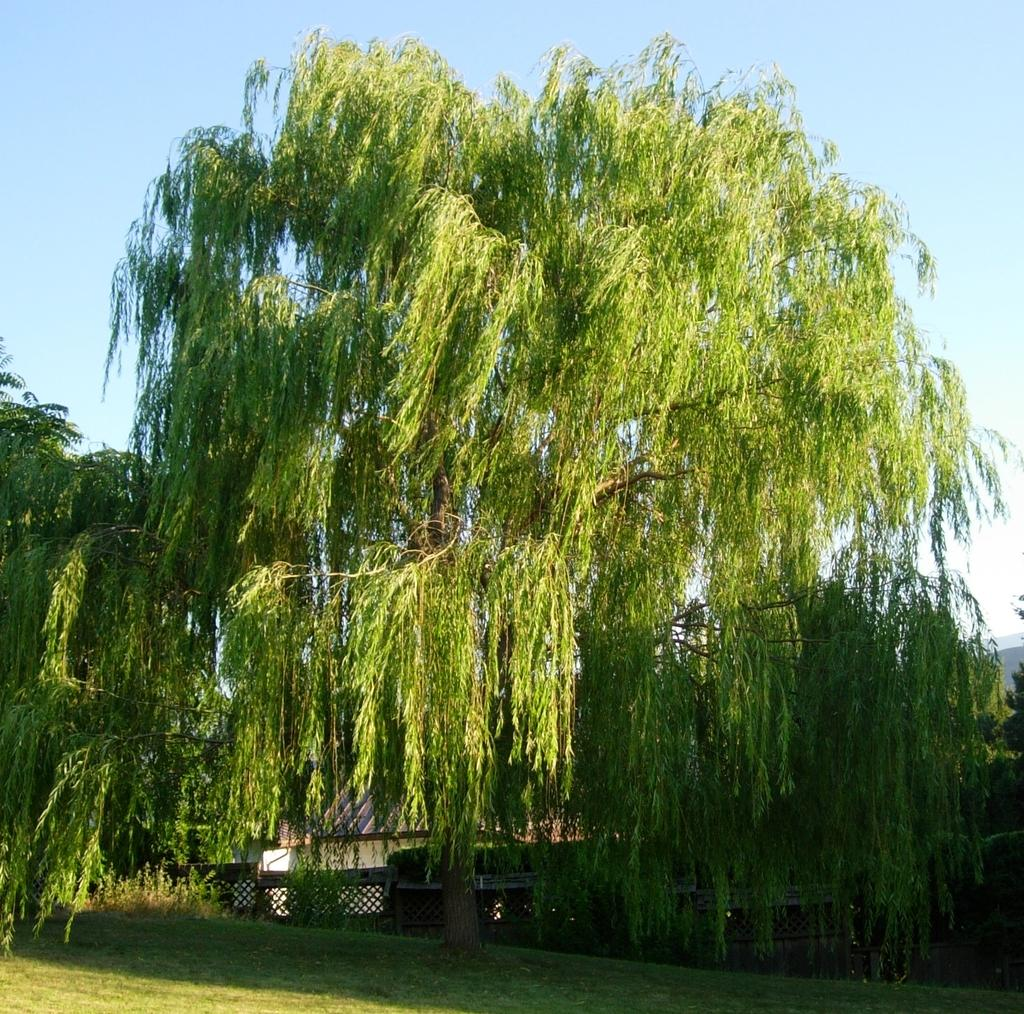What type of natural vegetation is present in the image? There is a group of trees in the image. What type of man-made structures can be seen in the image? There are buildings in the image. What part of the natural environment is visible in the image? The sky is visible in the background of the image. What type of aftermath can be seen in the image? There is no aftermath present in the image; it features a group of trees and buildings. Where is the drawer located in the image? There is no drawer present in the image. What type of fan is visible in the image? There is no fan present in the image. 